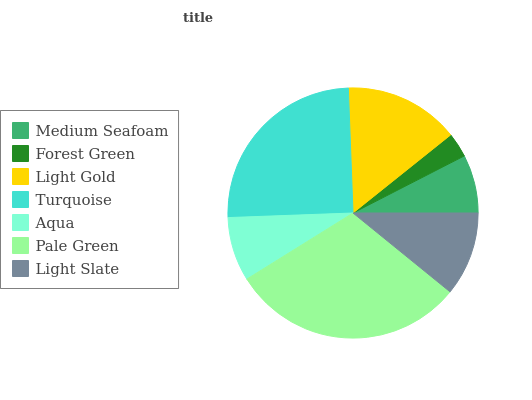Is Forest Green the minimum?
Answer yes or no. Yes. Is Pale Green the maximum?
Answer yes or no. Yes. Is Light Gold the minimum?
Answer yes or no. No. Is Light Gold the maximum?
Answer yes or no. No. Is Light Gold greater than Forest Green?
Answer yes or no. Yes. Is Forest Green less than Light Gold?
Answer yes or no. Yes. Is Forest Green greater than Light Gold?
Answer yes or no. No. Is Light Gold less than Forest Green?
Answer yes or no. No. Is Light Slate the high median?
Answer yes or no. Yes. Is Light Slate the low median?
Answer yes or no. Yes. Is Light Gold the high median?
Answer yes or no. No. Is Turquoise the low median?
Answer yes or no. No. 